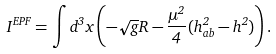Convert formula to latex. <formula><loc_0><loc_0><loc_500><loc_500>I ^ { E P F } = \int d ^ { 3 } x \left ( - \sqrt { g } R - \frac { \mu ^ { 2 } } { 4 } ( h _ { a b } ^ { 2 } - h ^ { 2 } ) \right ) .</formula> 